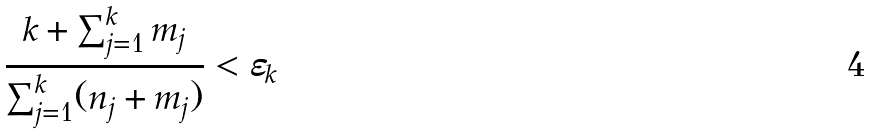<formula> <loc_0><loc_0><loc_500><loc_500>\frac { k + \sum _ { j = 1 } ^ { k } m _ { j } } { \sum _ { j = 1 } ^ { k } ( n _ { j } + m _ { j } ) } < \varepsilon _ { k }</formula> 